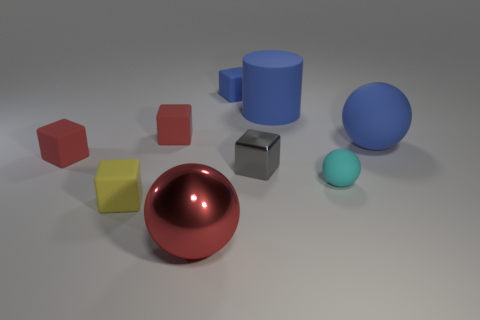If I were to place another object in this scene, which color do you think would contrast most with the existing palette? Adding an object in a strong complementary color, such as orange, could offer a striking contrast against the primarily cool blue tones and neutral grays in the current image. 